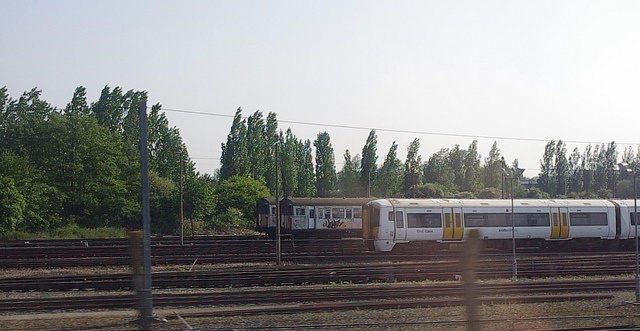Describe the objects in this image and their specific colors. I can see train in lightgray, gray, darkgray, and black tones, train in lightgray, gray, and black tones, and train in lightgray, black, and gray tones in this image. 